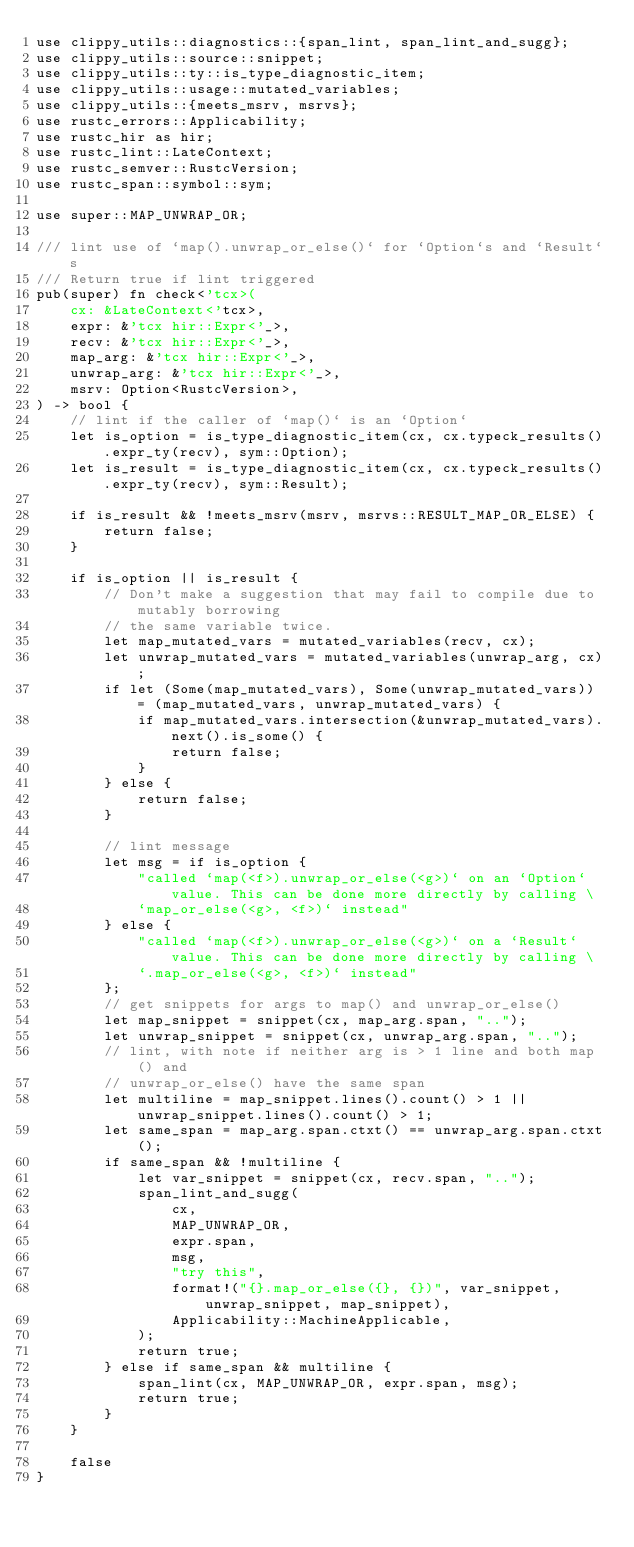Convert code to text. <code><loc_0><loc_0><loc_500><loc_500><_Rust_>use clippy_utils::diagnostics::{span_lint, span_lint_and_sugg};
use clippy_utils::source::snippet;
use clippy_utils::ty::is_type_diagnostic_item;
use clippy_utils::usage::mutated_variables;
use clippy_utils::{meets_msrv, msrvs};
use rustc_errors::Applicability;
use rustc_hir as hir;
use rustc_lint::LateContext;
use rustc_semver::RustcVersion;
use rustc_span::symbol::sym;

use super::MAP_UNWRAP_OR;

/// lint use of `map().unwrap_or_else()` for `Option`s and `Result`s
/// Return true if lint triggered
pub(super) fn check<'tcx>(
    cx: &LateContext<'tcx>,
    expr: &'tcx hir::Expr<'_>,
    recv: &'tcx hir::Expr<'_>,
    map_arg: &'tcx hir::Expr<'_>,
    unwrap_arg: &'tcx hir::Expr<'_>,
    msrv: Option<RustcVersion>,
) -> bool {
    // lint if the caller of `map()` is an `Option`
    let is_option = is_type_diagnostic_item(cx, cx.typeck_results().expr_ty(recv), sym::Option);
    let is_result = is_type_diagnostic_item(cx, cx.typeck_results().expr_ty(recv), sym::Result);

    if is_result && !meets_msrv(msrv, msrvs::RESULT_MAP_OR_ELSE) {
        return false;
    }

    if is_option || is_result {
        // Don't make a suggestion that may fail to compile due to mutably borrowing
        // the same variable twice.
        let map_mutated_vars = mutated_variables(recv, cx);
        let unwrap_mutated_vars = mutated_variables(unwrap_arg, cx);
        if let (Some(map_mutated_vars), Some(unwrap_mutated_vars)) = (map_mutated_vars, unwrap_mutated_vars) {
            if map_mutated_vars.intersection(&unwrap_mutated_vars).next().is_some() {
                return false;
            }
        } else {
            return false;
        }

        // lint message
        let msg = if is_option {
            "called `map(<f>).unwrap_or_else(<g>)` on an `Option` value. This can be done more directly by calling \
            `map_or_else(<g>, <f>)` instead"
        } else {
            "called `map(<f>).unwrap_or_else(<g>)` on a `Result` value. This can be done more directly by calling \
            `.map_or_else(<g>, <f>)` instead"
        };
        // get snippets for args to map() and unwrap_or_else()
        let map_snippet = snippet(cx, map_arg.span, "..");
        let unwrap_snippet = snippet(cx, unwrap_arg.span, "..");
        // lint, with note if neither arg is > 1 line and both map() and
        // unwrap_or_else() have the same span
        let multiline = map_snippet.lines().count() > 1 || unwrap_snippet.lines().count() > 1;
        let same_span = map_arg.span.ctxt() == unwrap_arg.span.ctxt();
        if same_span && !multiline {
            let var_snippet = snippet(cx, recv.span, "..");
            span_lint_and_sugg(
                cx,
                MAP_UNWRAP_OR,
                expr.span,
                msg,
                "try this",
                format!("{}.map_or_else({}, {})", var_snippet, unwrap_snippet, map_snippet),
                Applicability::MachineApplicable,
            );
            return true;
        } else if same_span && multiline {
            span_lint(cx, MAP_UNWRAP_OR, expr.span, msg);
            return true;
        }
    }

    false
}
</code> 